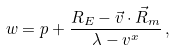Convert formula to latex. <formula><loc_0><loc_0><loc_500><loc_500>w = p + \frac { R _ { E } - \vec { v } \cdot \vec { R } _ { m } } { \lambda - v ^ { x } } \, ,</formula> 